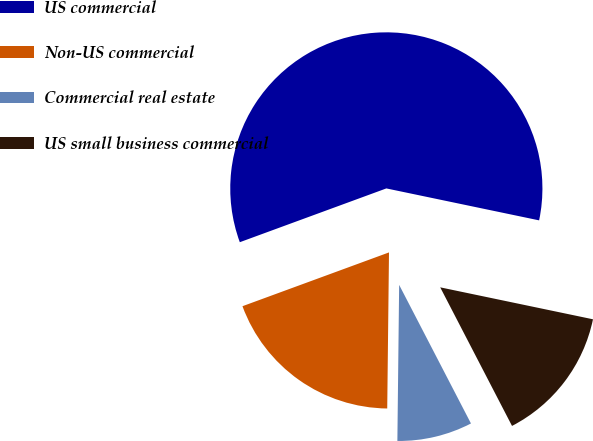Convert chart. <chart><loc_0><loc_0><loc_500><loc_500><pie_chart><fcel>US commercial<fcel>Non-US commercial<fcel>Commercial real estate<fcel>US small business commercial<nl><fcel>58.88%<fcel>19.22%<fcel>7.79%<fcel>14.11%<nl></chart> 